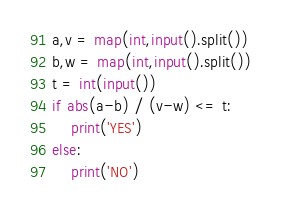Convert code to text. <code><loc_0><loc_0><loc_500><loc_500><_Python_>a,v = map(int,input().split())
b,w = map(int,input().split())
t = int(input())
if abs(a-b) / (v-w) <= t:
    print('YES')
else:
    print('NO')</code> 